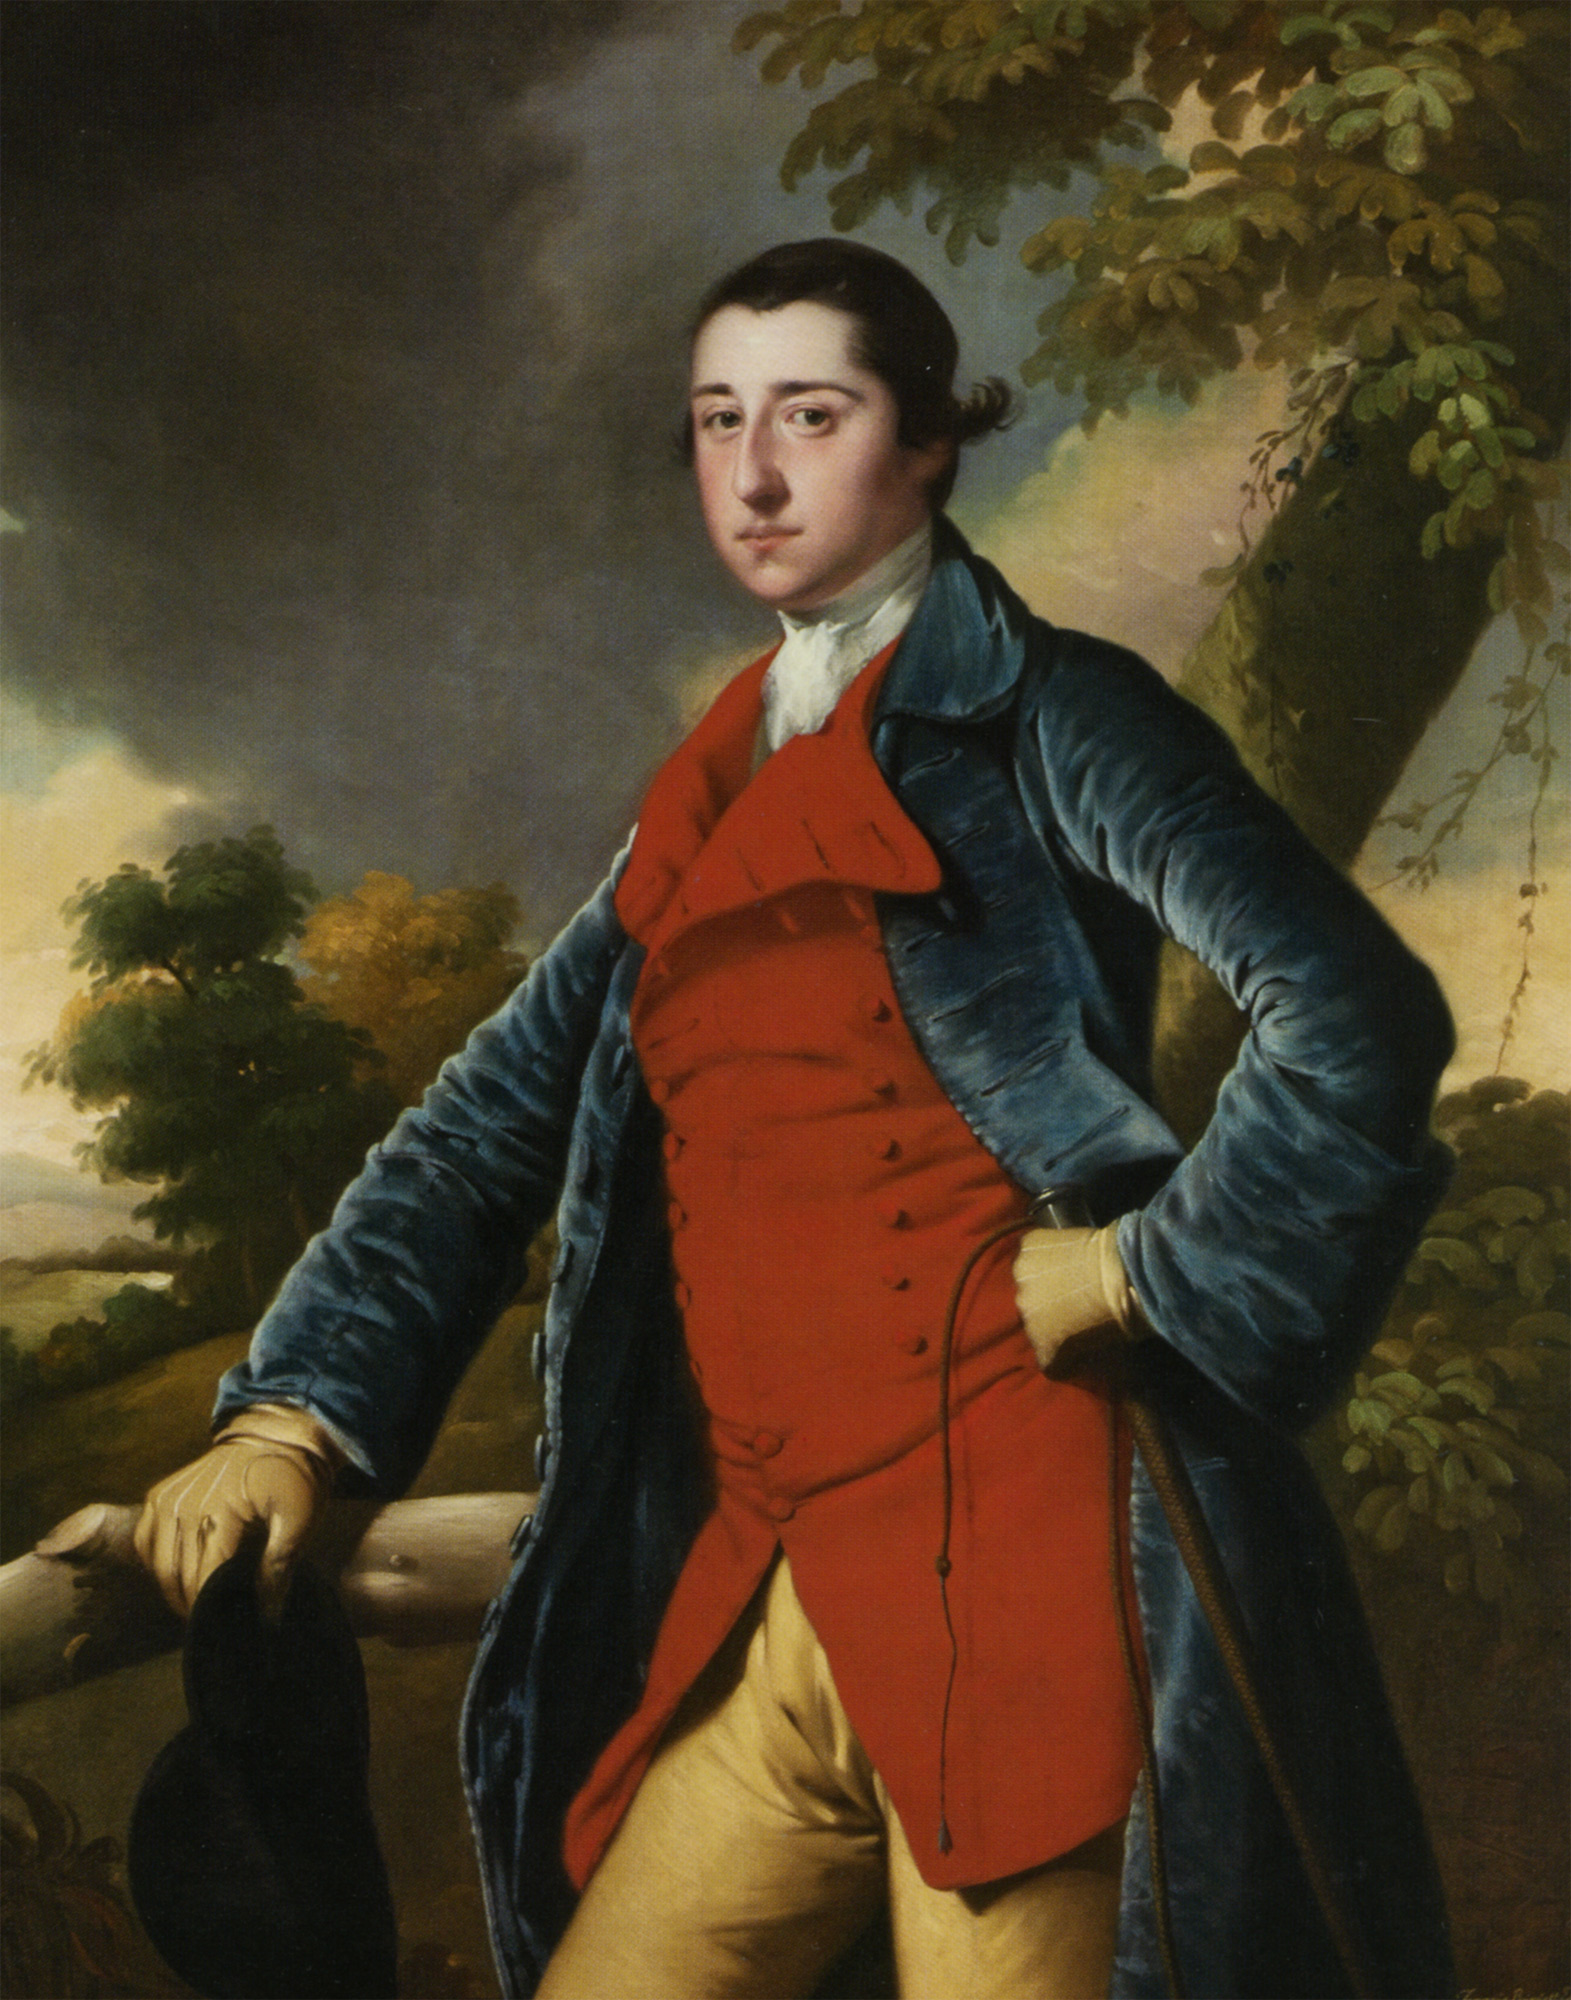Can you explain the significance of the clothing style in the image? The clothing style worn by the man is indicative of 18th-century European fashion, often worn by the upper classes. The choice of a blue velvet coat and gold buttons suggests wealth and status, as such materials were expensive. The red waistcoat and yellow breeches also reflect popular fashion trends of the time, emphasizing the man's social standing and fashion-consciousness. 